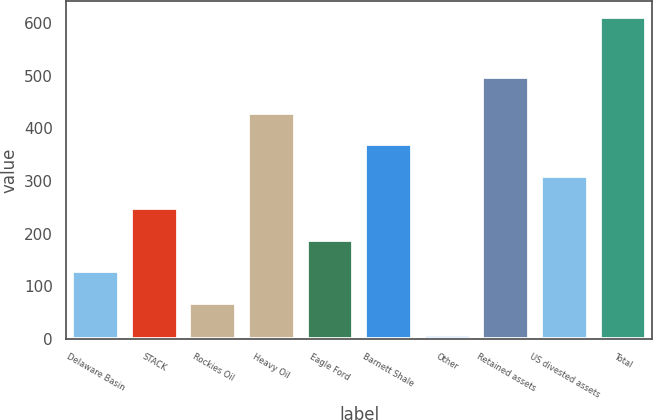<chart> <loc_0><loc_0><loc_500><loc_500><bar_chart><fcel>Delaware Basin<fcel>STACK<fcel>Rockies Oil<fcel>Heavy Oil<fcel>Eagle Ford<fcel>Barnett Shale<fcel>Other<fcel>Retained assets<fcel>US divested assets<fcel>Total<nl><fcel>128.6<fcel>249.2<fcel>68.3<fcel>430.1<fcel>188.9<fcel>369.8<fcel>8<fcel>497<fcel>309.5<fcel>611<nl></chart> 